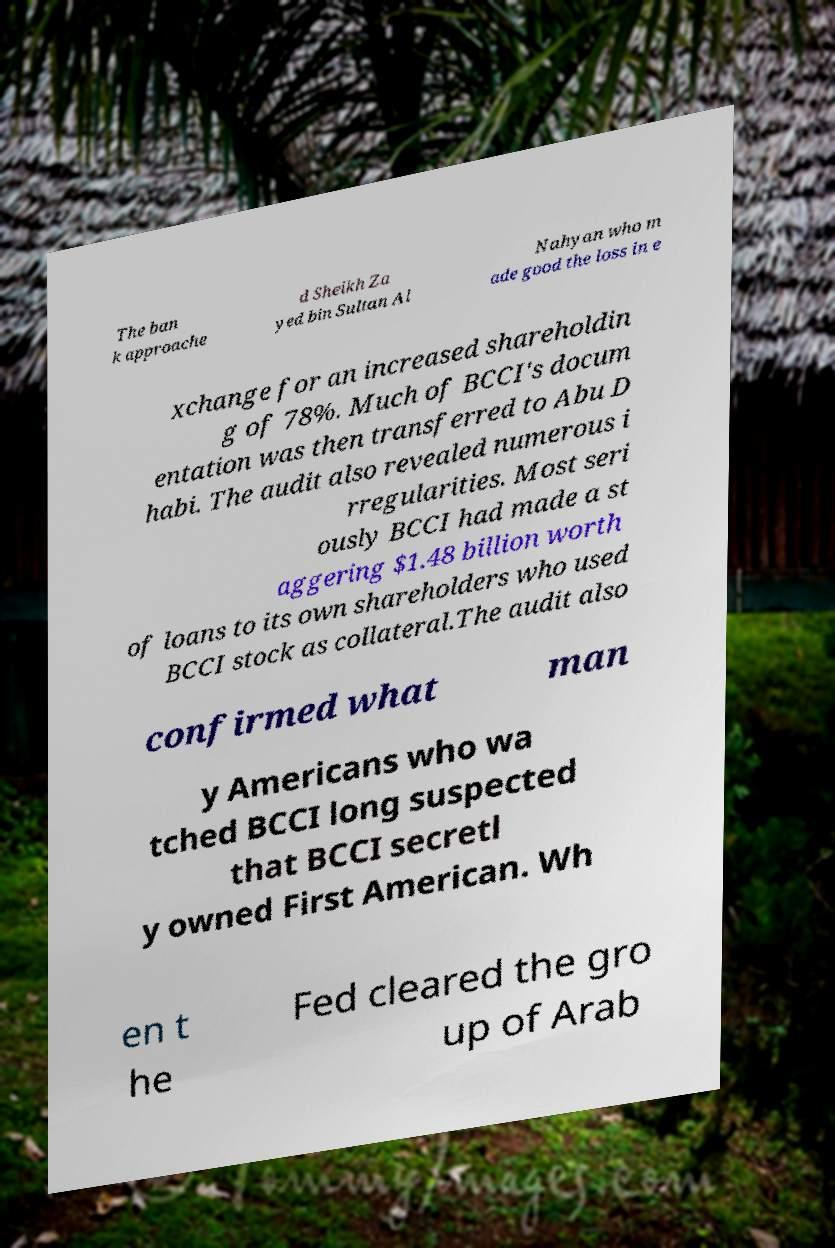For documentation purposes, I need the text within this image transcribed. Could you provide that? The ban k approache d Sheikh Za yed bin Sultan Al Nahyan who m ade good the loss in e xchange for an increased shareholdin g of 78%. Much of BCCI's docum entation was then transferred to Abu D habi. The audit also revealed numerous i rregularities. Most seri ously BCCI had made a st aggering $1.48 billion worth of loans to its own shareholders who used BCCI stock as collateral.The audit also confirmed what man y Americans who wa tched BCCI long suspected that BCCI secretl y owned First American. Wh en t he Fed cleared the gro up of Arab 